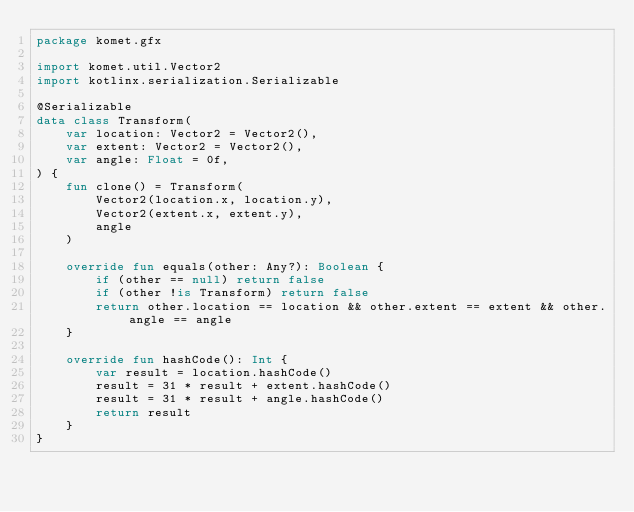<code> <loc_0><loc_0><loc_500><loc_500><_Kotlin_>package komet.gfx

import komet.util.Vector2
import kotlinx.serialization.Serializable

@Serializable
data class Transform(
    var location: Vector2 = Vector2(),
    var extent: Vector2 = Vector2(),
    var angle: Float = 0f,
) {
    fun clone() = Transform(
        Vector2(location.x, location.y),
        Vector2(extent.x, extent.y),
        angle
    )

    override fun equals(other: Any?): Boolean {
        if (other == null) return false
        if (other !is Transform) return false
        return other.location == location && other.extent == extent && other.angle == angle
    }

    override fun hashCode(): Int {
        var result = location.hashCode()
        result = 31 * result + extent.hashCode()
        result = 31 * result + angle.hashCode()
        return result
    }
}</code> 